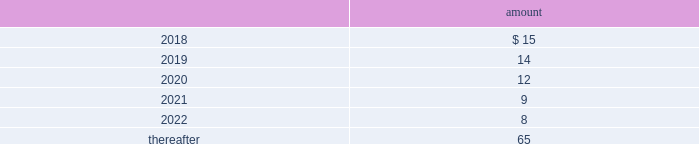Deposits 2014deposits include escrow funds and certain other deposits held in trust .
The company includes cash deposits in other current assets .
Deferred compensation obligations 2014the company 2019s deferred compensation plans allow participants to defer certain cash compensation into notional investment accounts .
The company includes such plans in other long-term liabilities .
The value of the company 2019s deferred compensation obligations is based on the market value of the participants 2019 notional investment accounts .
The notional investments are comprised primarily of mutual funds , which are based on observable market prices .
Mark-to-market derivative asset and liability 2014the company utilizes fixed-to-floating interest-rate swaps , typically designated as fair-value hedges , to achieve a targeted level of variable-rate debt as a percentage of total debt .
The company also employs derivative financial instruments in the form of variable-to-fixed interest rate swaps and forward starting interest rate swaps , classified as economic hedges and cash flow hedges , respectively , in order to fix the interest cost on existing or forecasted debt .
The company uses a calculation of future cash inflows and estimated future outflows , which are discounted , to determine the current fair value .
Additional inputs to the present value calculation include the contract terms , counterparty credit risk , interest rates and market volatility .
Other investments 2014other investments primarily represent money market funds used for active employee benefits .
The company includes other investments in other current assets .
Note 18 : leases the company has entered into operating leases involving certain facilities and equipment .
Rental expenses under operating leases were $ 29 million , $ 24 million and $ 21 million for the years ended december 31 , 2017 , 2016 and 2015 , respectively .
The operating leases for facilities will expire over the next 25 years and the operating leases for equipment will expire over the next 5 years .
Certain operating leases have renewal options ranging from one to five years .
The minimum annual future rental commitment under operating leases that have initial or remaining non-cancelable lease terms over the next 5 years and thereafter are as follows: .
The company has a series of agreements with various public entities ( the 201cpartners 201d ) to establish certain joint ventures , commonly referred to as 201cpublic-private partnerships . 201d under the public-private partnerships , the company constructed utility plant , financed by the company and the partners constructed utility plant ( connected to the company 2019s property ) , financed by the partners .
The company agreed to transfer and convey some of its real and personal property to the partners in exchange for an equal principal amount of industrial development bonds ( 201cidbs 201d ) , issued by the partners under a state industrial development bond and commercial development act .
The company leased back the total facilities , including portions funded by both the company and the partners , under leases for a period of 40 years .
The leases related to the portion of the facilities funded by the company have required payments from the company to the partners that approximate the payments required by the terms of the idbs from the partners to the company ( as the holder of the idbs ) .
As the ownership of the portion of the facilities constructed by the .
What was the change in the rental amount from 2017 to 2018 in millions? 
Rationale: the change is the difference between the two periods
Computations: (29 - 15)
Answer: 14.0. 